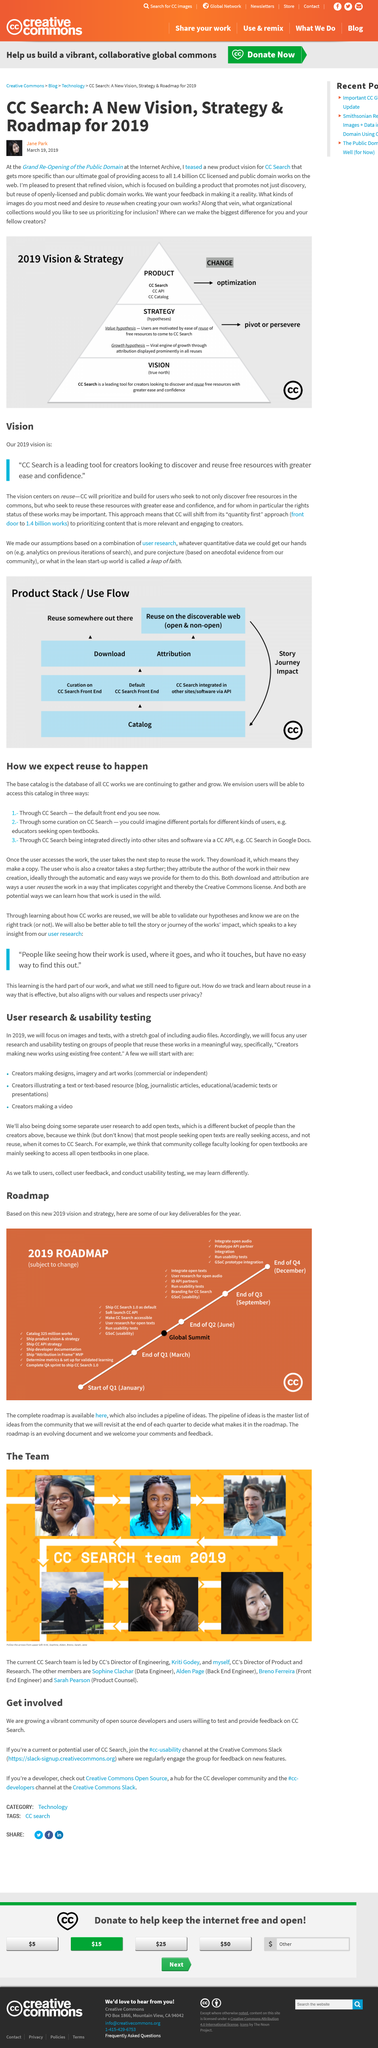List a handful of essential elements in this visual. The ultimate goal of the vision is to make it possible for everyone to access all 1.4 billion CC licensed and public domain works on the web. In 2019, the focus will be solely on images and texts. The stretch goal for 2019 will be audio files. Jane Park presented the 2019 Vision and Strategy during the year 2019. The Grand Re-Opening of the Public Domain was the venue where the 2019 Vision and Strategy was presented to the public for the first time. 